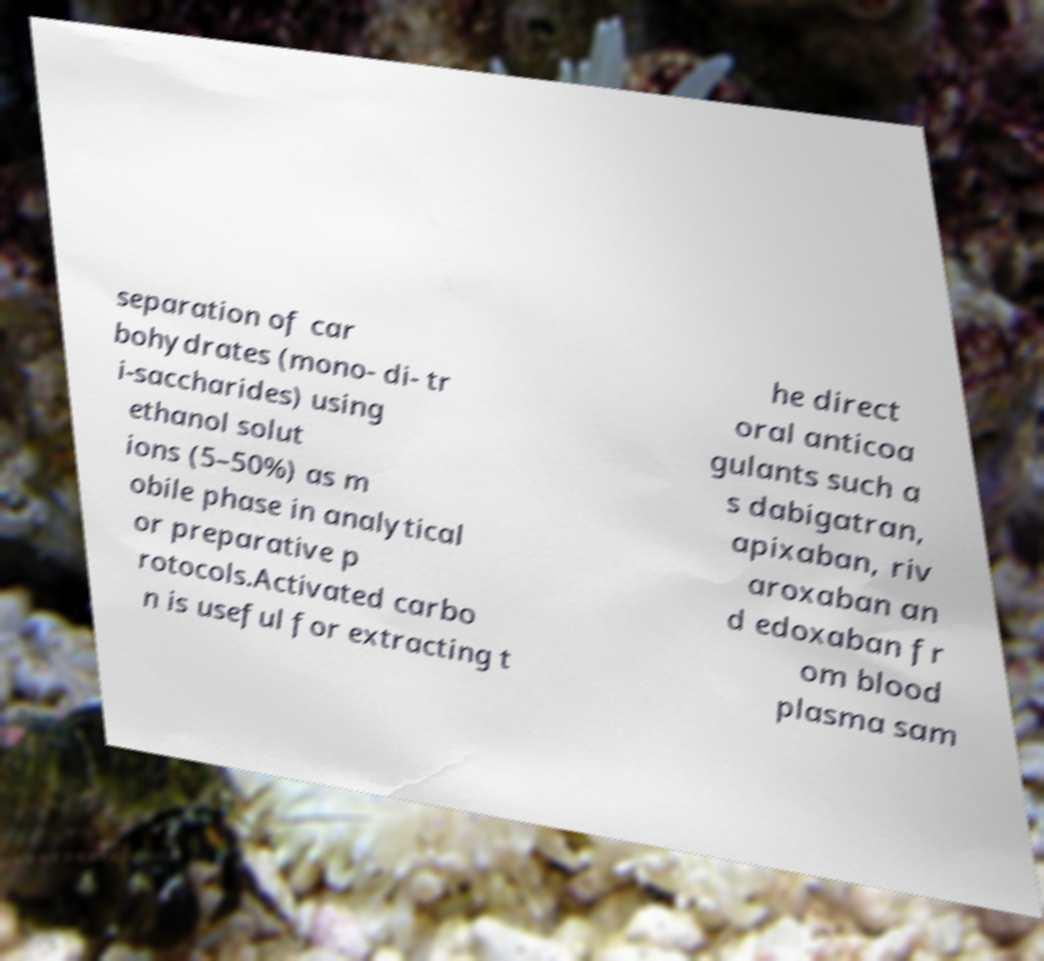I need the written content from this picture converted into text. Can you do that? separation of car bohydrates (mono- di- tr i-saccharides) using ethanol solut ions (5–50%) as m obile phase in analytical or preparative p rotocols.Activated carbo n is useful for extracting t he direct oral anticoa gulants such a s dabigatran, apixaban, riv aroxaban an d edoxaban fr om blood plasma sam 